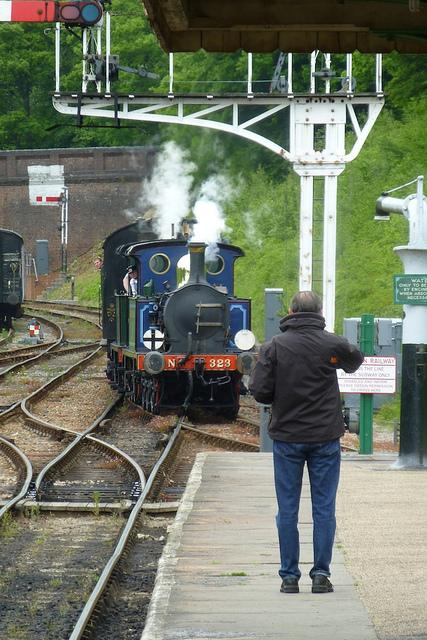Why are the people travelling on the train? reach destination 